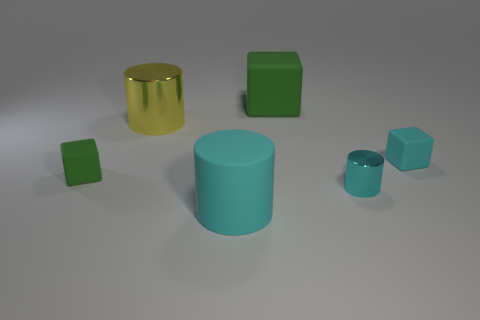Add 3 large matte cubes. How many objects exist? 9 Subtract all tiny blue matte objects. Subtract all green matte blocks. How many objects are left? 4 Add 1 small cyan objects. How many small cyan objects are left? 3 Add 2 tiny cyan cubes. How many tiny cyan cubes exist? 3 Subtract 0 gray cylinders. How many objects are left? 6 